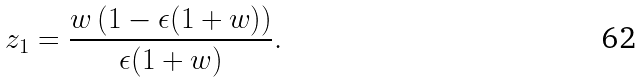Convert formula to latex. <formula><loc_0><loc_0><loc_500><loc_500>z _ { 1 } = \frac { w \left ( 1 - \epsilon ( 1 + w ) \right ) } { \epsilon ( 1 + w ) } .</formula> 